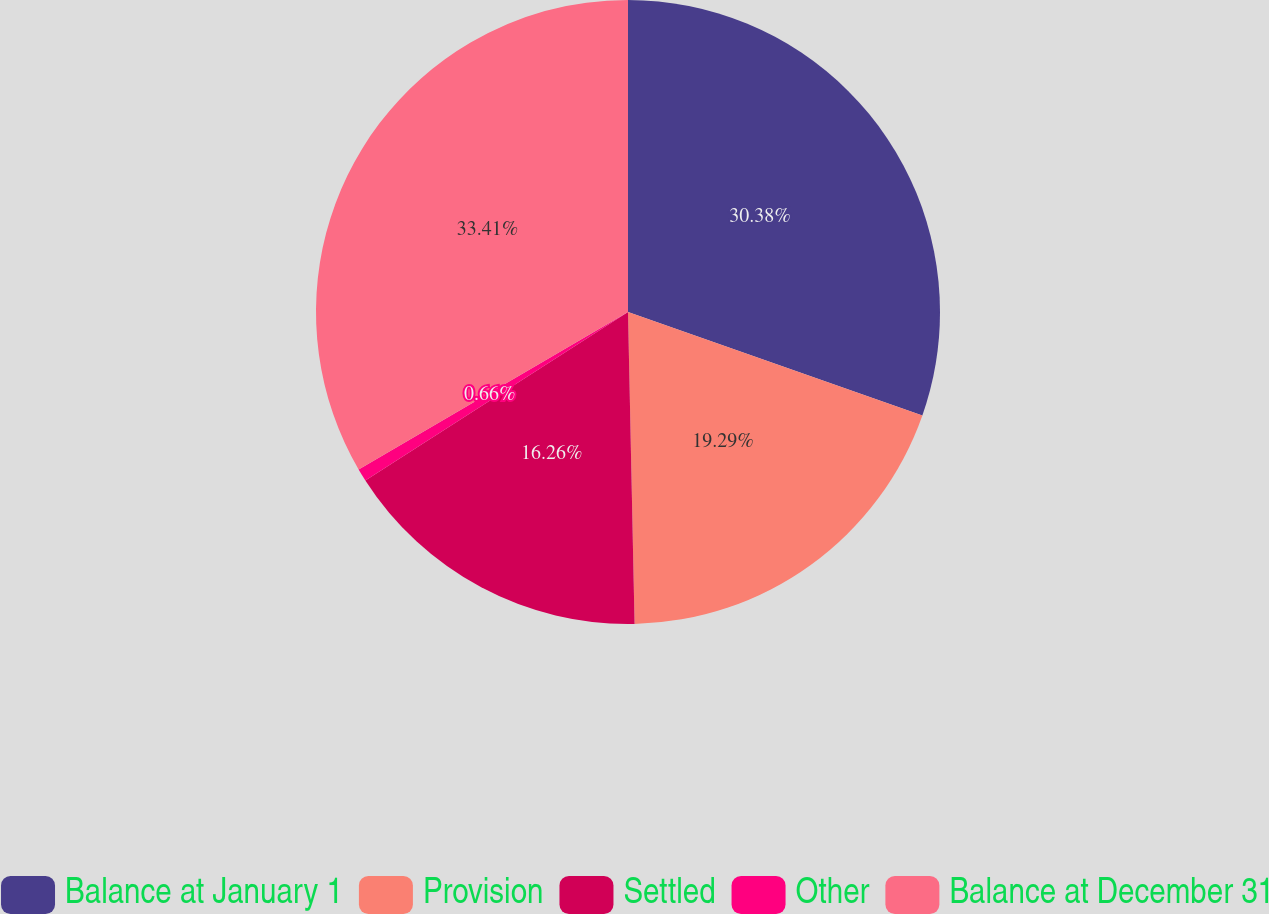Convert chart to OTSL. <chart><loc_0><loc_0><loc_500><loc_500><pie_chart><fcel>Balance at January 1<fcel>Provision<fcel>Settled<fcel>Other<fcel>Balance at December 31<nl><fcel>30.38%<fcel>19.29%<fcel>16.26%<fcel>0.66%<fcel>33.42%<nl></chart> 